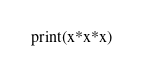<code> <loc_0><loc_0><loc_500><loc_500><_Python_>print(x*x*x)</code> 